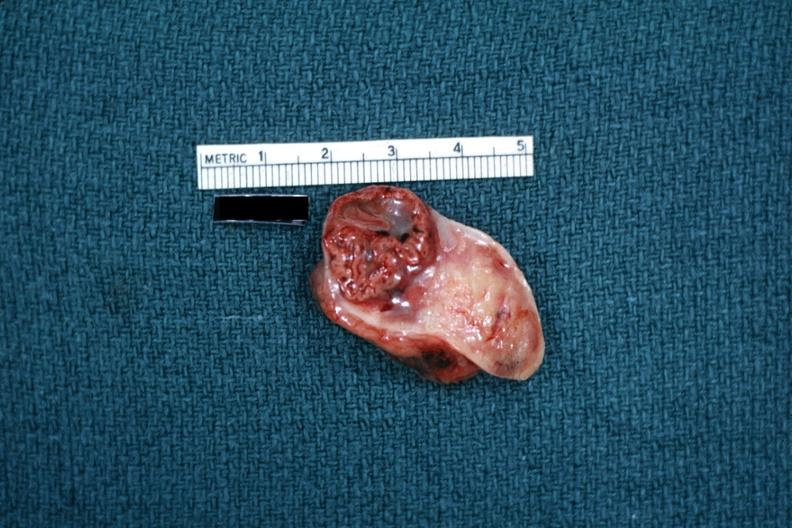s glomerulosa present?
Answer the question using a single word or phrase. No 